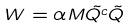Convert formula to latex. <formula><loc_0><loc_0><loc_500><loc_500>W = \alpha M \tilde { Q ^ { c } } \tilde { Q }</formula> 